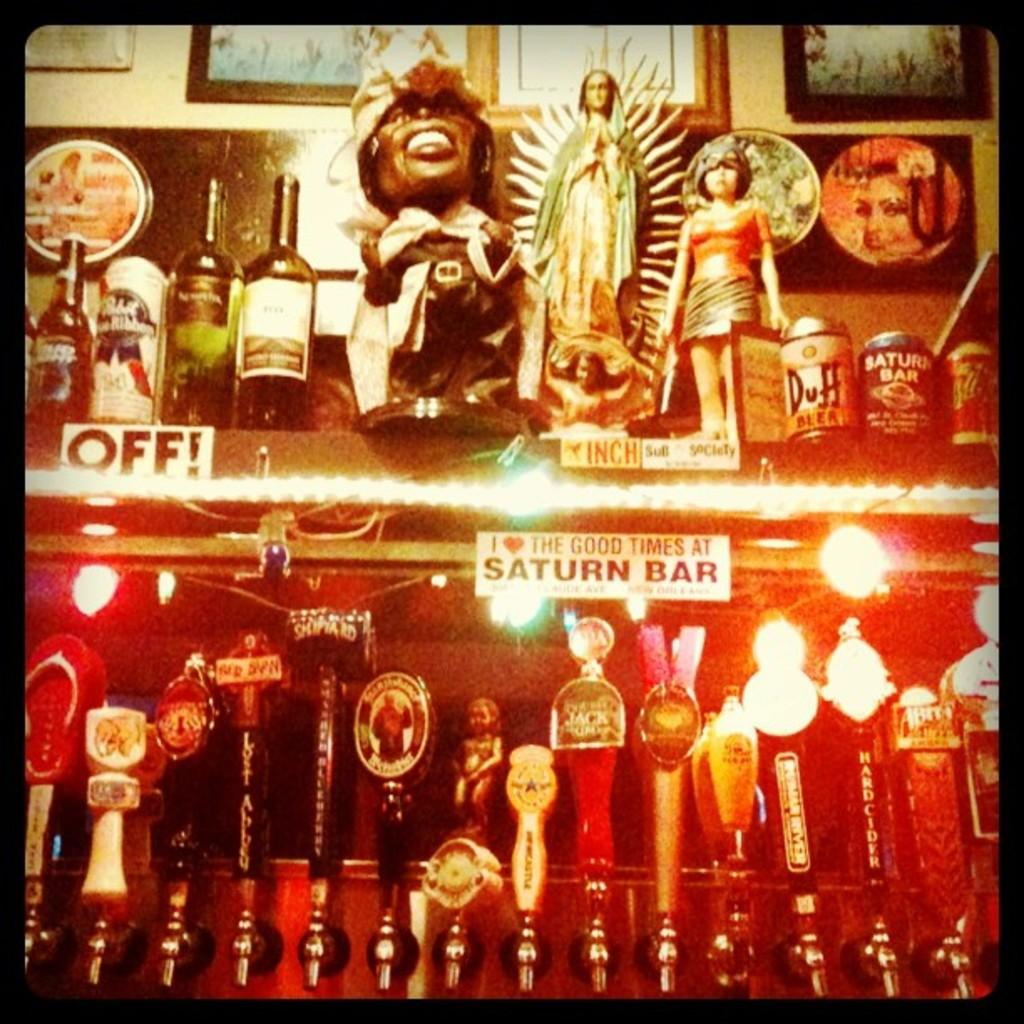<image>
Present a compact description of the photo's key features. The Good Times Saturn Bar bumper sticker attached to a shelf with beer drafts under it. 